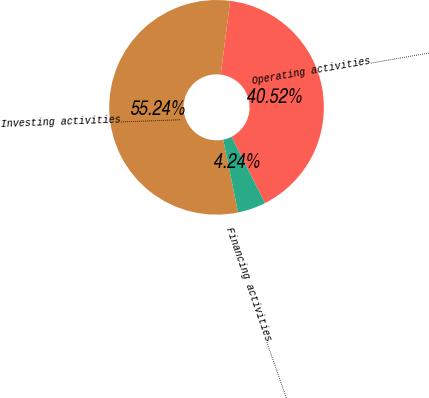<chart> <loc_0><loc_0><loc_500><loc_500><pie_chart><fcel>Operating activities…………………………<fcel>Investing activities…………………………<fcel>Financing activities…………………………<nl><fcel>40.52%<fcel>55.25%<fcel>4.24%<nl></chart> 